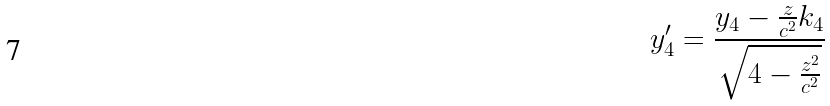Convert formula to latex. <formula><loc_0><loc_0><loc_500><loc_500>y _ { 4 } ^ { \prime } = \frac { y _ { 4 } - \frac { z } { c ^ { 2 } } k _ { 4 } } { \sqrt { 4 - \frac { z ^ { 2 } } { c ^ { 2 } } } }</formula> 